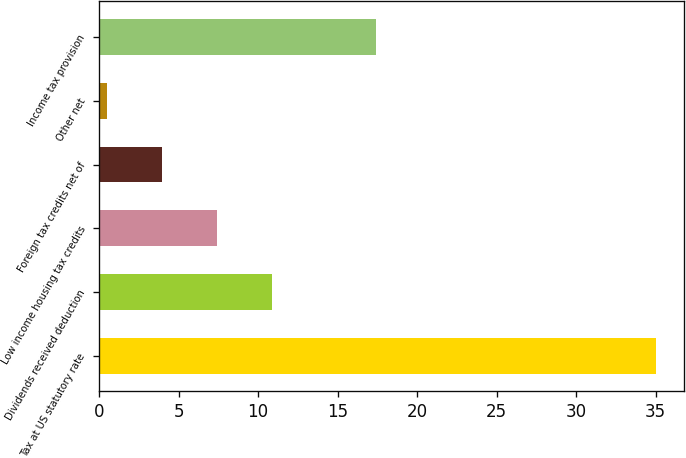<chart> <loc_0><loc_0><loc_500><loc_500><bar_chart><fcel>Tax at US statutory rate<fcel>Dividends received deduction<fcel>Low income housing tax credits<fcel>Foreign tax credits net of<fcel>Other net<fcel>Income tax provision<nl><fcel>35<fcel>10.85<fcel>7.4<fcel>3.95<fcel>0.5<fcel>17.4<nl></chart> 